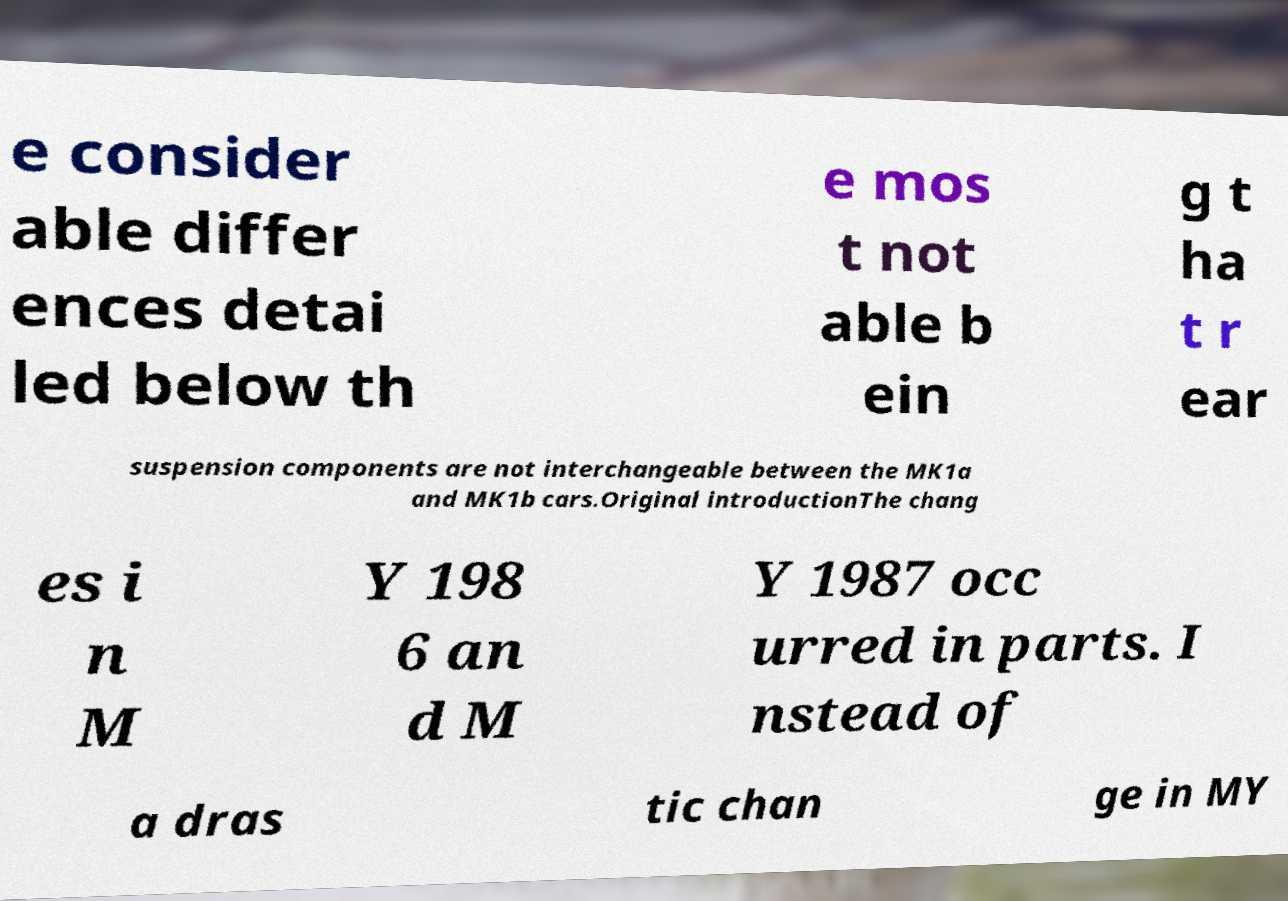For documentation purposes, I need the text within this image transcribed. Could you provide that? e consider able differ ences detai led below th e mos t not able b ein g t ha t r ear suspension components are not interchangeable between the MK1a and MK1b cars.Original introductionThe chang es i n M Y 198 6 an d M Y 1987 occ urred in parts. I nstead of a dras tic chan ge in MY 